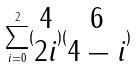<formula> <loc_0><loc_0><loc_500><loc_500>\sum _ { i = 0 } ^ { 2 } ( \begin{matrix} 4 \\ 2 i \end{matrix} ) ( \begin{matrix} 6 \\ 4 - i \end{matrix} )</formula> 